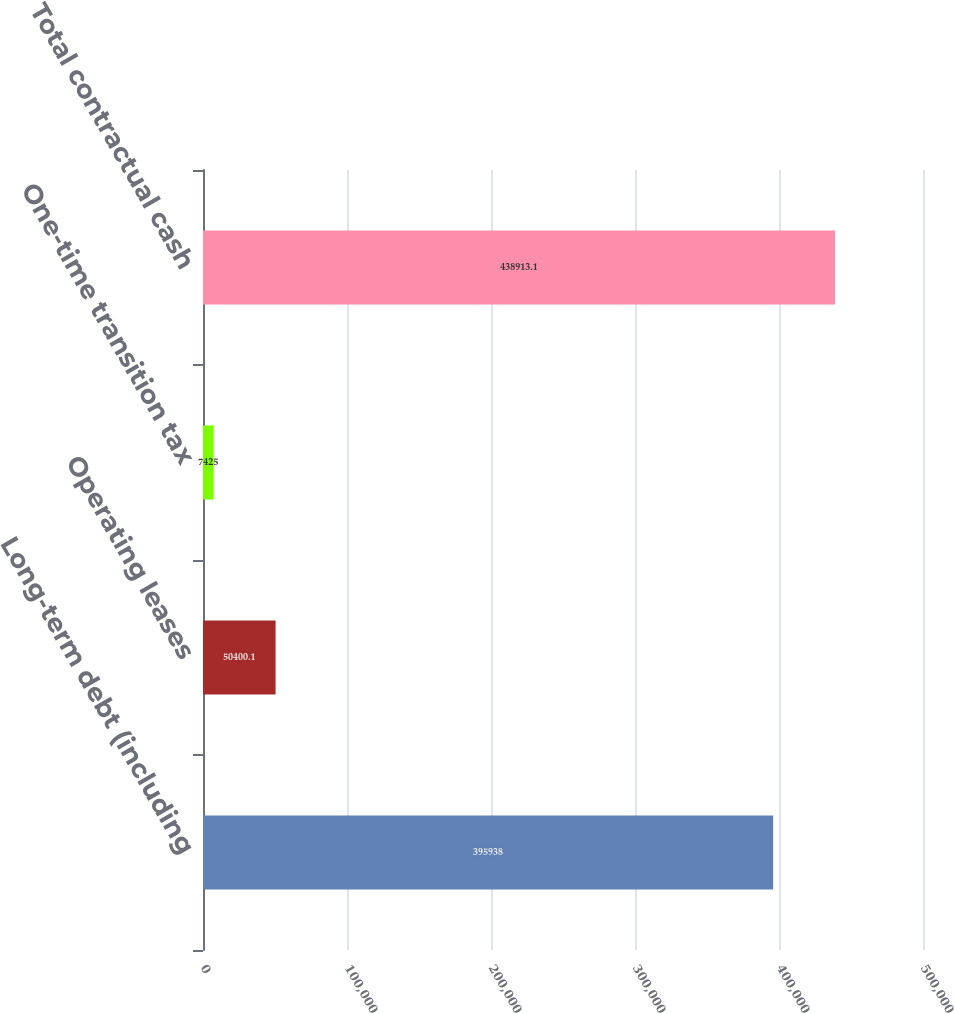<chart> <loc_0><loc_0><loc_500><loc_500><bar_chart><fcel>Long-term debt (including<fcel>Operating leases<fcel>One-time transition tax<fcel>Total contractual cash<nl><fcel>395938<fcel>50400.1<fcel>7425<fcel>438913<nl></chart> 